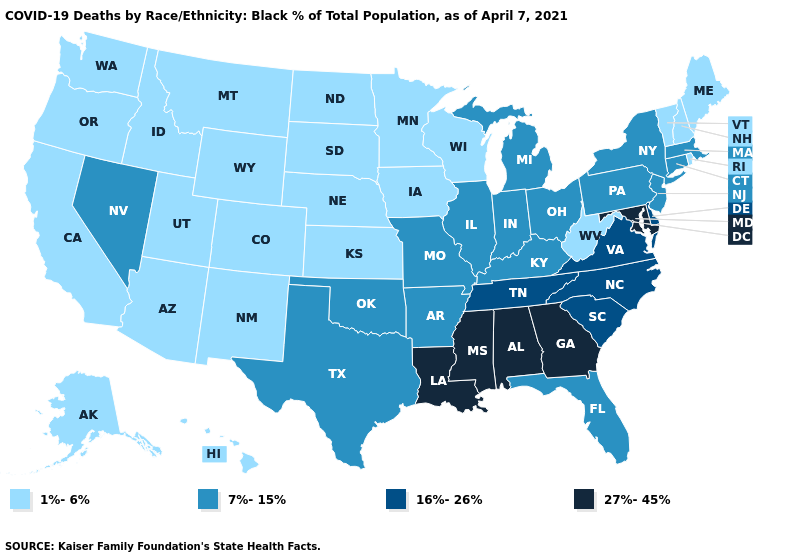Among the states that border Mississippi , which have the highest value?
Short answer required. Alabama, Louisiana. What is the value of South Dakota?
Write a very short answer. 1%-6%. How many symbols are there in the legend?
Quick response, please. 4. Does Florida have the highest value in the South?
Quick response, please. No. What is the value of Kentucky?
Write a very short answer. 7%-15%. What is the highest value in states that border Illinois?
Be succinct. 7%-15%. Name the states that have a value in the range 1%-6%?
Give a very brief answer. Alaska, Arizona, California, Colorado, Hawaii, Idaho, Iowa, Kansas, Maine, Minnesota, Montana, Nebraska, New Hampshire, New Mexico, North Dakota, Oregon, Rhode Island, South Dakota, Utah, Vermont, Washington, West Virginia, Wisconsin, Wyoming. What is the value of Missouri?
Short answer required. 7%-15%. Does Ohio have a lower value than Missouri?
Short answer required. No. Does Montana have the lowest value in the USA?
Concise answer only. Yes. Name the states that have a value in the range 27%-45%?
Short answer required. Alabama, Georgia, Louisiana, Maryland, Mississippi. Does Mississippi have the same value as Rhode Island?
Quick response, please. No. Name the states that have a value in the range 16%-26%?
Give a very brief answer. Delaware, North Carolina, South Carolina, Tennessee, Virginia. What is the highest value in the West ?
Write a very short answer. 7%-15%. Among the states that border Iowa , does South Dakota have the lowest value?
Write a very short answer. Yes. 